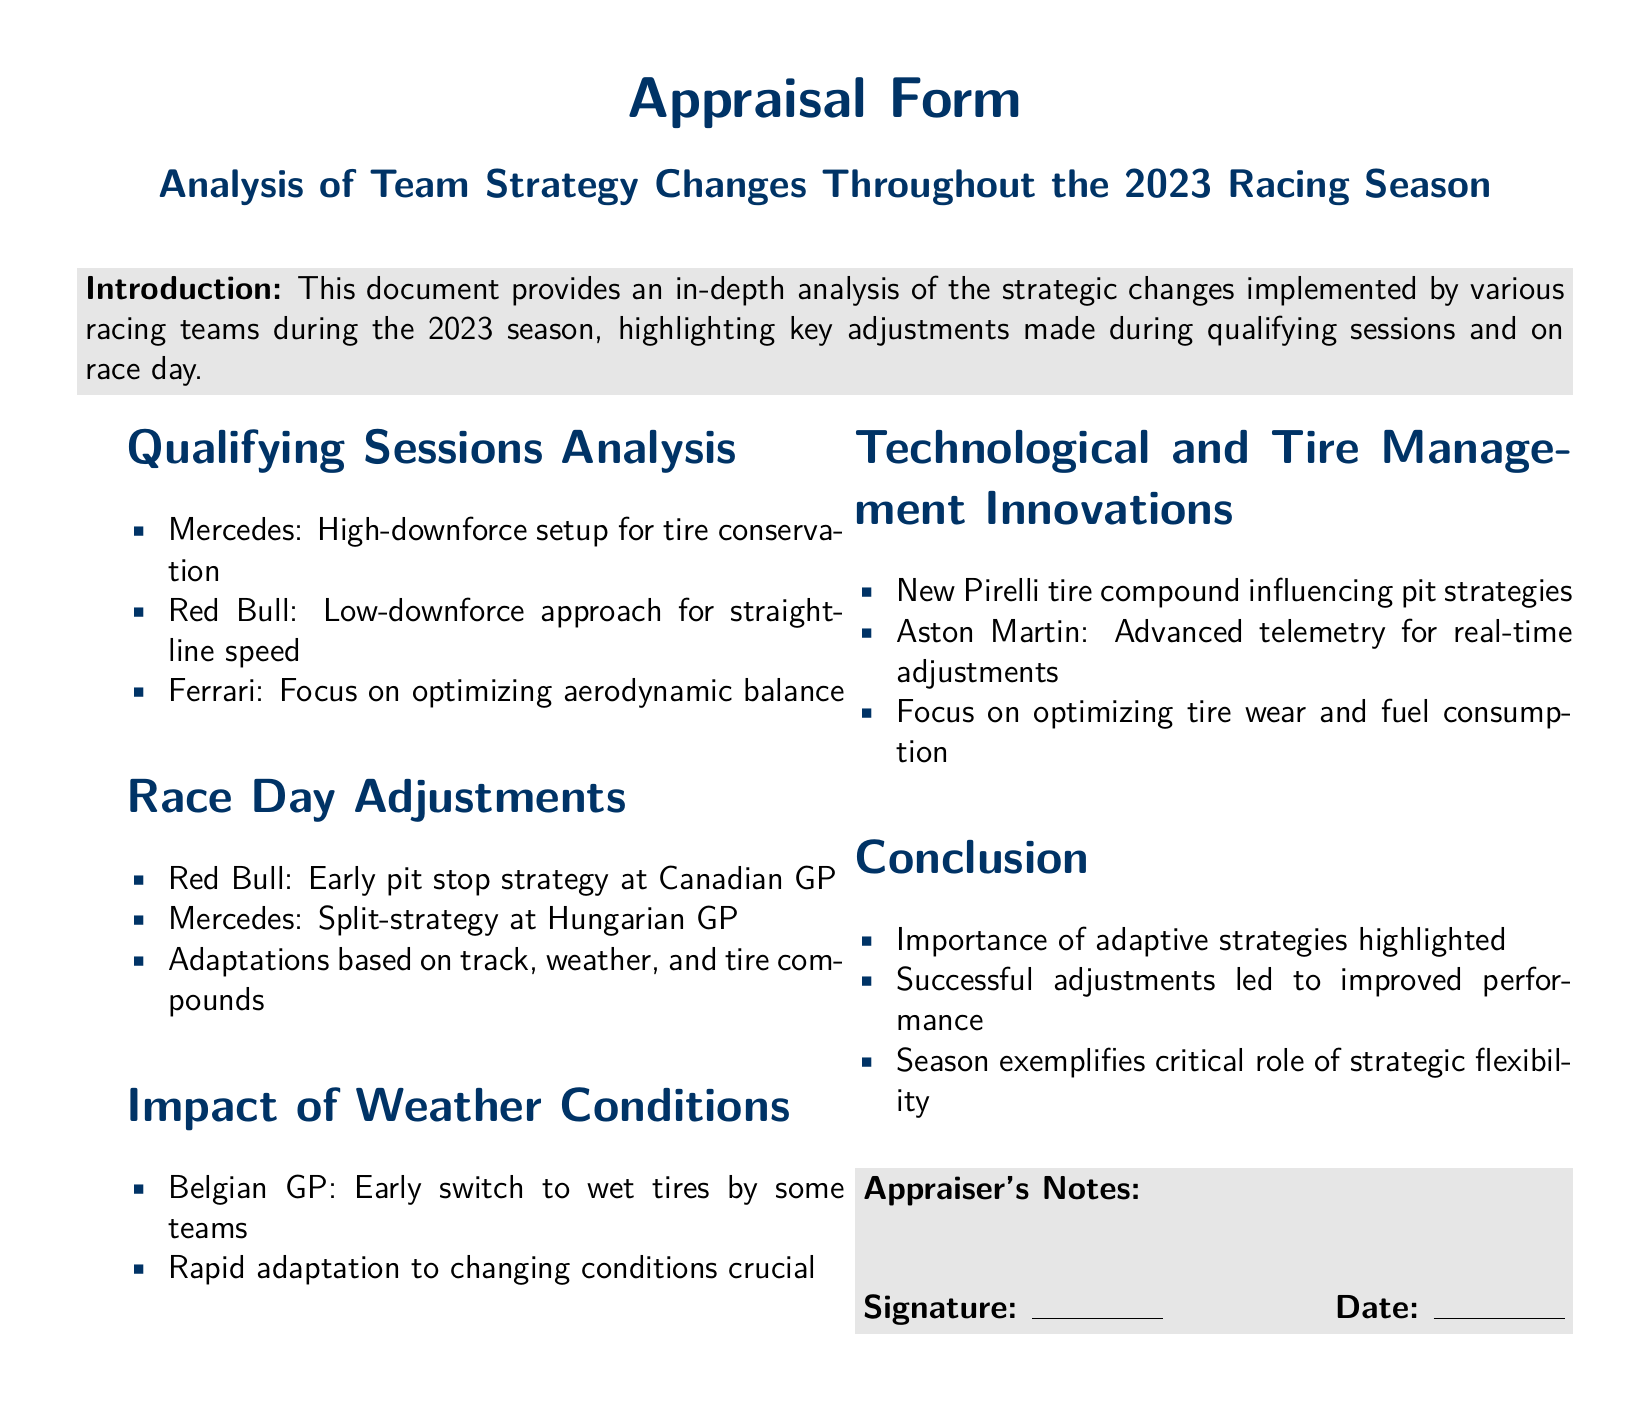What was Mercedes' qualifying setup? The document states that Mercedes implemented a high-downforce setup during qualifying sessions for tire conservation.
Answer: High-downforce setup for tire conservation What strategy did Red Bull use at the Canadian GP? The document indicates that Red Bull executed an early pit stop strategy during the Canadian GP race day.
Answer: Early pit stop strategy at Canadian GP Which team focused on optimizing aerodynamic balance? The analysis mentions Ferrari's focus on optimizing aerodynamic balance in qualifying sessions.
Answer: Ferrari What innovative technology did Aston Martin use? According to the document, Aston Martin utilized advanced telemetry for real-time adjustments to their strategy.
Answer: Advanced telemetry for real-time adjustments What was highlighted in the conclusion regarding adaptive strategies? The conclusion emphasizes the importance of adaptive strategies in improving team performance during the season.
Answer: Importance of adaptive strategies highlighted Which weather condition influenced tire strategies during the Belgian GP? The document notes that the early switch to wet tires was a factor for some teams during the Belgian GP due to weather conditions.
Answer: Early switch to wet tires What was the impact of new Pirelli tire compounds mentioned in the document? The document indicates that new Pirelli tire compounds influenced teams' pit strategies throughout the season.
Answer: Influencing pit strategies What does the document illustrate regarding the role of strategic flexibility? It illustrates that the season exemplifies the critical role of strategic flexibility for successful team adjustments.
Answer: Critical role of strategic flexibility 